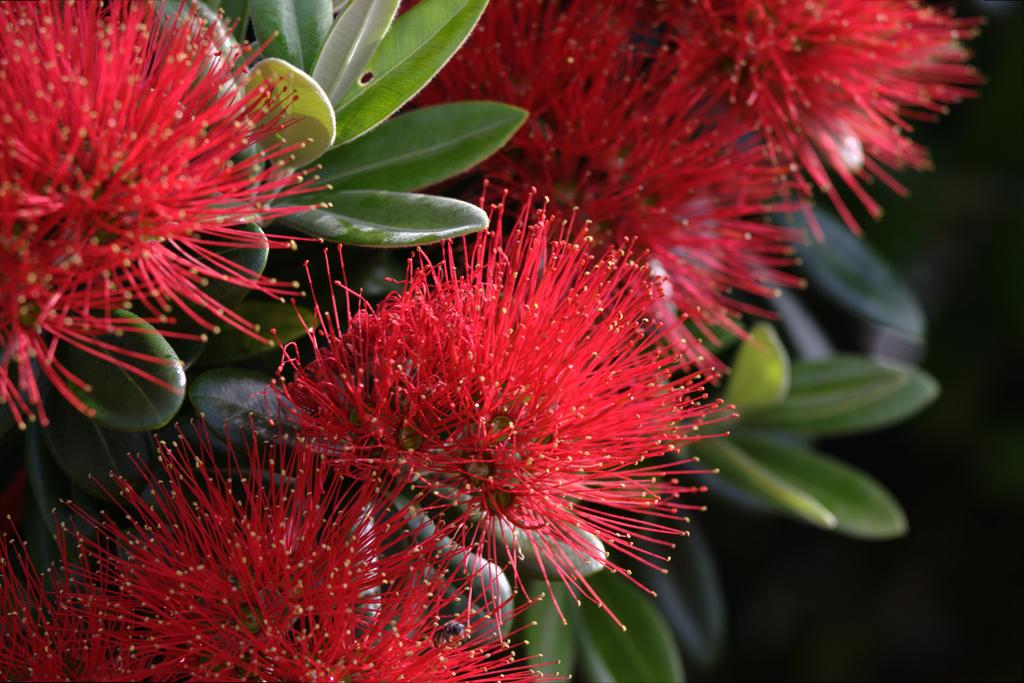What type of plant life can be seen in the image? There are flowers and leaves in the image. Can you describe the flowers in the image? Unfortunately, the facts provided do not give specific details about the flowers. What is the color of the leaves in the image? The facts provided do not specify the color of the leaves. What type of instrument is being played by the thumb in the image? There is no thumb or instrument present in the image. How many keys are visible on the keychain in the image? There is no keychain or keys present in the image. 